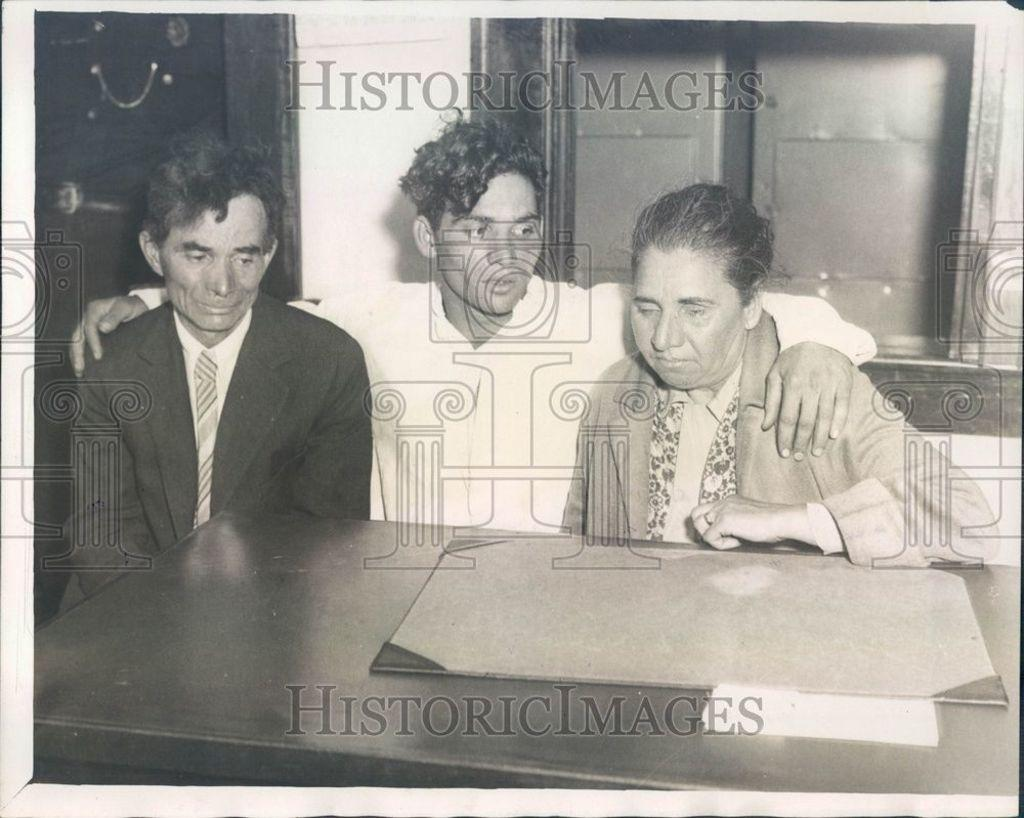What is the main object in the image? There is a table in the image. What are the people in the image doing? There are people sitting at the table. What can be seen in the background of the image? There is a wall and a door in the background of the image. What type of pie is being served at the table in the image? There is no pie present in the image; it only shows people sitting at a table. 